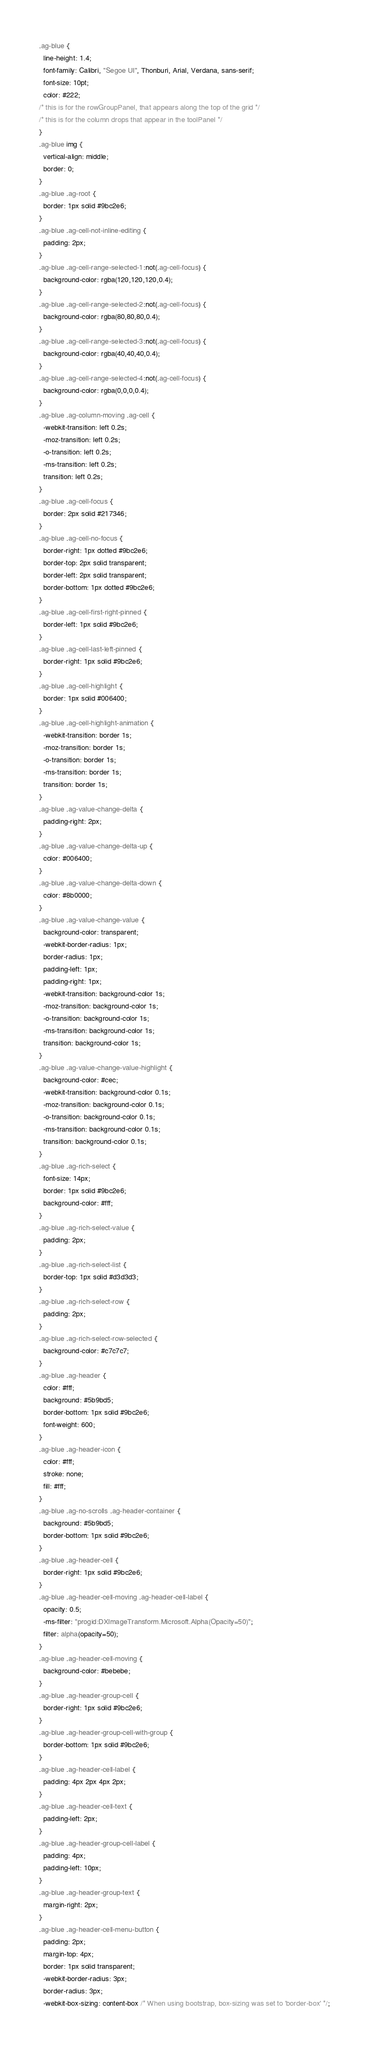Convert code to text. <code><loc_0><loc_0><loc_500><loc_500><_CSS_>.ag-blue {
  line-height: 1.4;
  font-family: Calibri, "Segoe UI", Thonburi, Arial, Verdana, sans-serif;
  font-size: 10pt;
  color: #222;
/* this is for the rowGroupPanel, that appears along the top of the grid */
/* this is for the column drops that appear in the toolPanel */
}
.ag-blue img {
  vertical-align: middle;
  border: 0;
}
.ag-blue .ag-root {
  border: 1px solid #9bc2e6;
}
.ag-blue .ag-cell-not-inline-editing {
  padding: 2px;
}
.ag-blue .ag-cell-range-selected-1:not(.ag-cell-focus) {
  background-color: rgba(120,120,120,0.4);
}
.ag-blue .ag-cell-range-selected-2:not(.ag-cell-focus) {
  background-color: rgba(80,80,80,0.4);
}
.ag-blue .ag-cell-range-selected-3:not(.ag-cell-focus) {
  background-color: rgba(40,40,40,0.4);
}
.ag-blue .ag-cell-range-selected-4:not(.ag-cell-focus) {
  background-color: rgba(0,0,0,0.4);
}
.ag-blue .ag-column-moving .ag-cell {
  -webkit-transition: left 0.2s;
  -moz-transition: left 0.2s;
  -o-transition: left 0.2s;
  -ms-transition: left 0.2s;
  transition: left 0.2s;
}
.ag-blue .ag-cell-focus {
  border: 2px solid #217346;
}
.ag-blue .ag-cell-no-focus {
  border-right: 1px dotted #9bc2e6;
  border-top: 2px solid transparent;
  border-left: 2px solid transparent;
  border-bottom: 1px dotted #9bc2e6;
}
.ag-blue .ag-cell-first-right-pinned {
  border-left: 1px solid #9bc2e6;
}
.ag-blue .ag-cell-last-left-pinned {
  border-right: 1px solid #9bc2e6;
}
.ag-blue .ag-cell-highlight {
  border: 1px solid #006400;
}
.ag-blue .ag-cell-highlight-animation {
  -webkit-transition: border 1s;
  -moz-transition: border 1s;
  -o-transition: border 1s;
  -ms-transition: border 1s;
  transition: border 1s;
}
.ag-blue .ag-value-change-delta {
  padding-right: 2px;
}
.ag-blue .ag-value-change-delta-up {
  color: #006400;
}
.ag-blue .ag-value-change-delta-down {
  color: #8b0000;
}
.ag-blue .ag-value-change-value {
  background-color: transparent;
  -webkit-border-radius: 1px;
  border-radius: 1px;
  padding-left: 1px;
  padding-right: 1px;
  -webkit-transition: background-color 1s;
  -moz-transition: background-color 1s;
  -o-transition: background-color 1s;
  -ms-transition: background-color 1s;
  transition: background-color 1s;
}
.ag-blue .ag-value-change-value-highlight {
  background-color: #cec;
  -webkit-transition: background-color 0.1s;
  -moz-transition: background-color 0.1s;
  -o-transition: background-color 0.1s;
  -ms-transition: background-color 0.1s;
  transition: background-color 0.1s;
}
.ag-blue .ag-rich-select {
  font-size: 14px;
  border: 1px solid #9bc2e6;
  background-color: #fff;
}
.ag-blue .ag-rich-select-value {
  padding: 2px;
}
.ag-blue .ag-rich-select-list {
  border-top: 1px solid #d3d3d3;
}
.ag-blue .ag-rich-select-row {
  padding: 2px;
}
.ag-blue .ag-rich-select-row-selected {
  background-color: #c7c7c7;
}
.ag-blue .ag-header {
  color: #fff;
  background: #5b9bd5;
  border-bottom: 1px solid #9bc2e6;
  font-weight: 600;
}
.ag-blue .ag-header-icon {
  color: #fff;
  stroke: none;
  fill: #fff;
}
.ag-blue .ag-no-scrolls .ag-header-container {
  background: #5b9bd5;
  border-bottom: 1px solid #9bc2e6;
}
.ag-blue .ag-header-cell {
  border-right: 1px solid #9bc2e6;
}
.ag-blue .ag-header-cell-moving .ag-header-cell-label {
  opacity: 0.5;
  -ms-filter: "progid:DXImageTransform.Microsoft.Alpha(Opacity=50)";
  filter: alpha(opacity=50);
}
.ag-blue .ag-header-cell-moving {
  background-color: #bebebe;
}
.ag-blue .ag-header-group-cell {
  border-right: 1px solid #9bc2e6;
}
.ag-blue .ag-header-group-cell-with-group {
  border-bottom: 1px solid #9bc2e6;
}
.ag-blue .ag-header-cell-label {
  padding: 4px 2px 4px 2px;
}
.ag-blue .ag-header-cell-text {
  padding-left: 2px;
}
.ag-blue .ag-header-group-cell-label {
  padding: 4px;
  padding-left: 10px;
}
.ag-blue .ag-header-group-text {
  margin-right: 2px;
}
.ag-blue .ag-header-cell-menu-button {
  padding: 2px;
  margin-top: 4px;
  border: 1px solid transparent;
  -webkit-border-radius: 3px;
  border-radius: 3px;
  -webkit-box-sizing: content-box /* When using bootstrap, box-sizing was set to 'border-box' */;</code> 